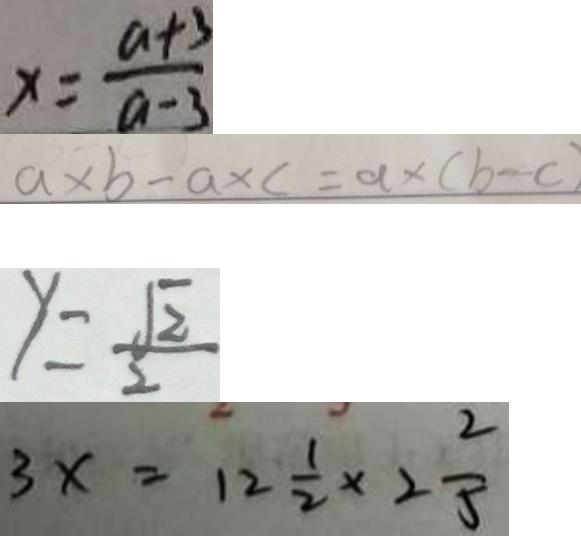Convert formula to latex. <formula><loc_0><loc_0><loc_500><loc_500>x = \frac { a + 3 } { a - 3 } 
 a \times b - a \times c = a \times ( b - c ) 
 y = \frac { \sqrt { 2 } } { 2 } 
 3 x = 1 2 \frac { 1 } { 2 } \times 2 \frac { 2 } { 5 }</formula> 